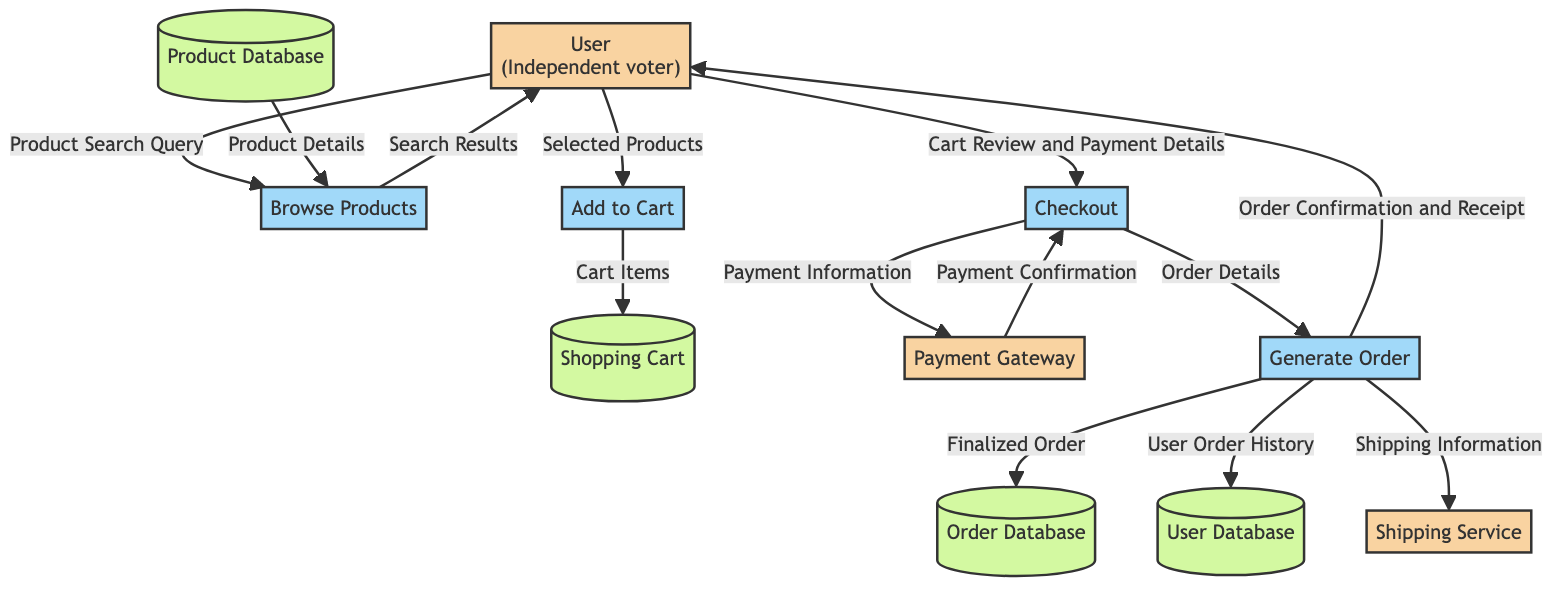What is the first process a user engages with? The first interaction in the flow is represented by the "Browse Products" process, which the User initiates when they input a product search query.
Answer: Browse Products How many data stores are present in the diagram? The diagram includes four data stores: Product Database, Shopping Cart, User Database, and Order Database. By counting these entities, we find the total is four.
Answer: 4 What information does the User provide during Checkout? During the Checkout process, the User provides "Cart Review and Payment Details" as their input, which drives the subsequent actions in this part of the flow.
Answer: Cart Review and Payment Details What does the "Add to Cart" process store in the "Shopping Cart"? The "Add to Cart" process transfers "Cart Items" to the Shopping Cart data store, which temporarily holds the selected products the user intends to purchase.
Answer: Cart Items What is the final output of the "Generate Order" process? The final outputs generated by the "Generate Order" process include "Order Confirmation and Receipt," which is provided to the user after finalizing the order.
Answer: Order Confirmation and Receipt What secure service processes payment information during Checkout? The "Payment Gateway" is designated as the external service that processes user payment information securely when the user is in the Checkout phase.
Answer: Payment Gateway Which entity receives shipping information after the order is generated? The "Shipping Service" is the entity that receives the shipping information as part of the output from the "Generate Order" process, linking order fulfillment to the final delivery.
Answer: Shipping Service How is the User's order history updated? The "Generate Order" process updates the "User Database" with the "User Order History" to reflect the latest completed purchases and maintain records for the user.
Answer: User Order History What data does the user receive after the order is finalized? After generating the order, the user receives an "Order Confirmation and Receipt," serving as a summary of their purchase and transaction details.
Answer: Order Confirmation and Receipt 